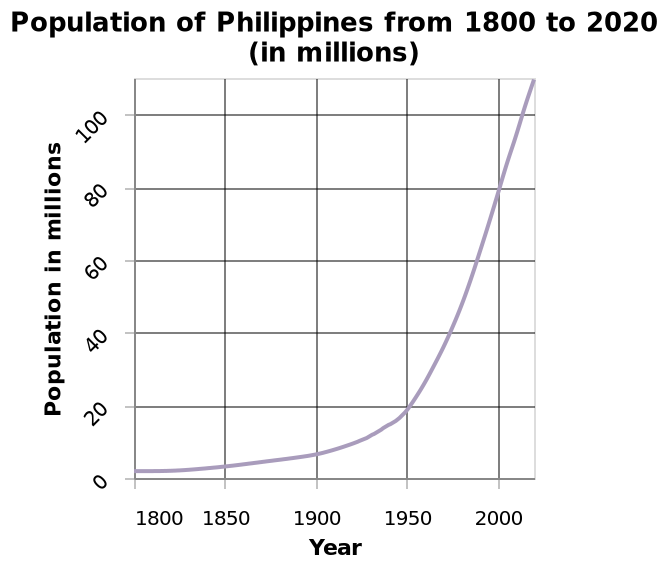<image>
What was the population in 1950?  The population in 1950 was around 20 million. When did the population start to increase?  The population has been increasing since 1800. 